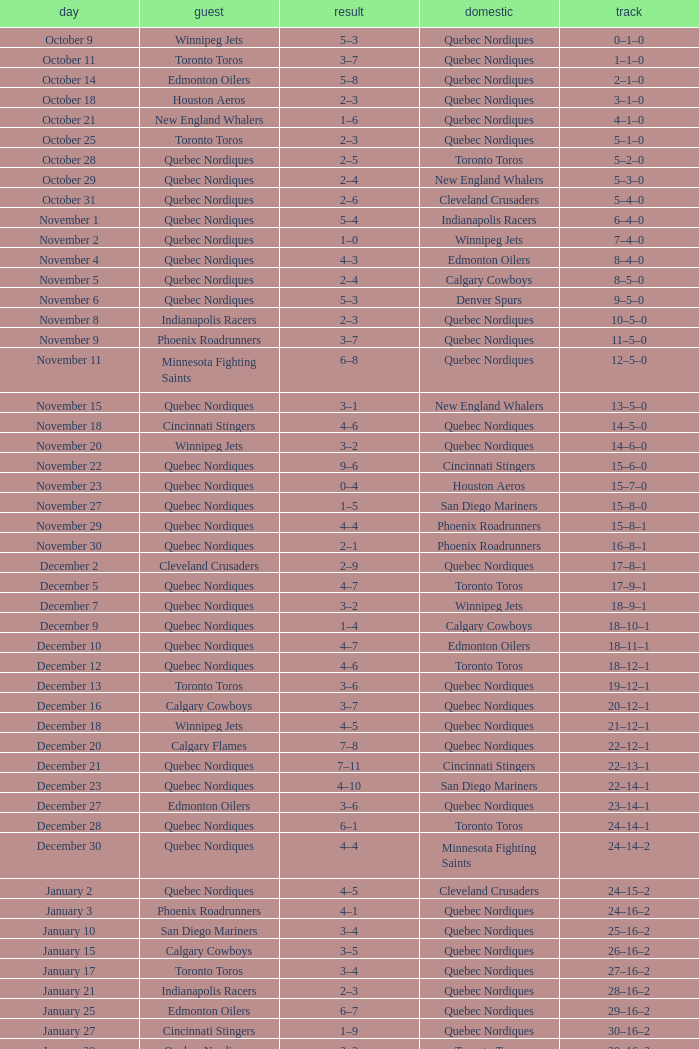What was the date of the game with a score of 2–1? November 30. 